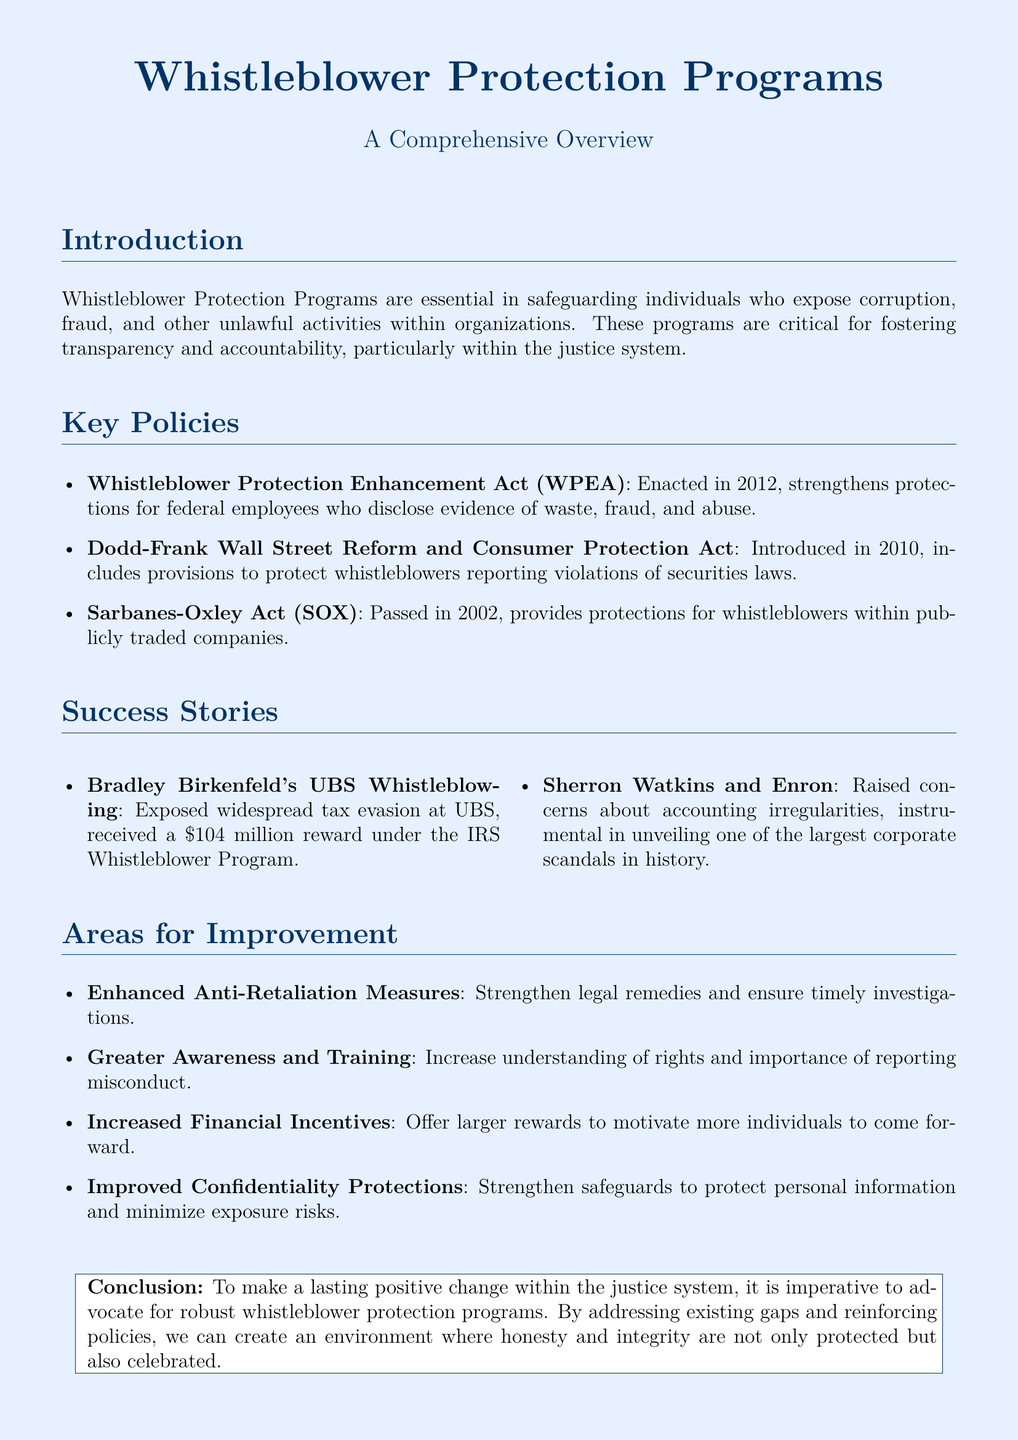What is the title of the document? The title is the main heading presented at the top of the document, which summarizes the content.
Answer: Whistleblower Protection Programs What year was the Whistleblower Protection Enhancement Act enacted? The act is specifically mentioned in the section outlining key policies, which includes its enactment date.
Answer: 2012 Who was rewarded $104 million for whistleblowing? This specific individual is noted in the success stories section for exposing tax evasion and receiving a significant reward.
Answer: Bradley Birkenfeld What is one area for improvement suggested in the document? The document lists several areas for improvement, focusing on enhancing aspects of whistleblower protection.
Answer: Enhanced Anti-Retaliation Measures Which law included provisions to protect whistleblowers reporting violations of securities laws? This detail is found in the key policies section, summarizing important legislative acts.
Answer: Dodd-Frank Wall Street Reform and Consumer Protection Act How many success stories are highlighted in the document? The document explicitly mentions the number of success stories provided within the success stories section.
Answer: Two What is a recommended change for whistleblower incentives? This suggestion reflects a key area for improvement concerning how to better motivate individuals to report misconduct.
Answer: Increased Financial Incentives Who raised concerns about accounting irregularities at Enron? The individual's name is detailed in the success stories section, highlighting their contribution to a significant corporate scandal.
Answer: Sherron Watkins 